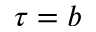<formula> <loc_0><loc_0><loc_500><loc_500>\tau = b</formula> 